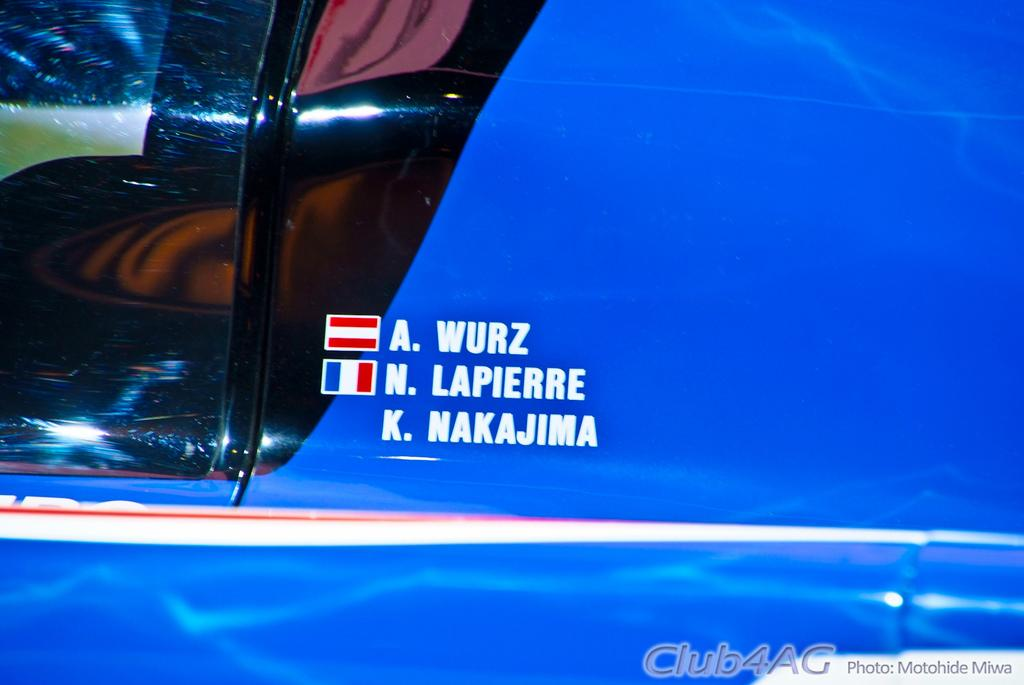What is the main subject of the image? The main subject of the image is a vehicle. What can be seen on the vehicle? The vehicle has text and flag symbols on it. What arithmetic problem is being solved on the vehicle in the image? There is no arithmetic problem visible on the vehicle in the image. What team is represented by the vehicle in the image? The image does not provide information about any team affiliation with the vehicle. 